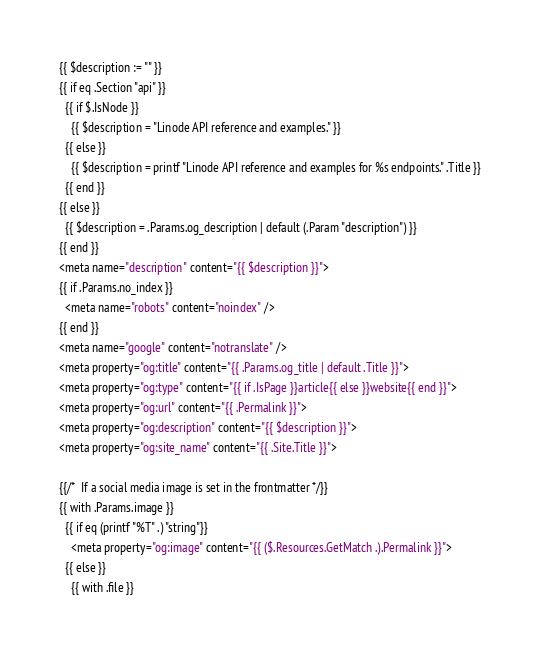Convert code to text. <code><loc_0><loc_0><loc_500><loc_500><_HTML_>{{ $description := "" }}
{{ if eq .Section "api" }}
  {{ if $.IsNode }}
    {{ $description = "Linode API reference and examples." }}
  {{ else }}
    {{ $description = printf "Linode API reference and examples for %s endpoints." .Title }}
  {{ end }}
{{ else }}
  {{ $description = .Params.og_description | default (.Param "description") }}
{{ end }}
<meta name="description" content="{{ $description }}">
{{ if .Params.no_index }}
  <meta name="robots" content="noindex" />
{{ end }}
<meta name="google" content="notranslate" />
<meta property="og:title" content="{{ .Params.og_title | default .Title }}">
<meta property="og:type" content="{{ if .IsPage }}article{{ else }}website{{ end }}">
<meta property="og:url" content="{{ .Permalink }}">
<meta property="og:description" content="{{ $description }}">
<meta property="og:site_name" content="{{ .Site.Title }}">

{{/*  If a social media image is set in the frontmatter */}}
{{ with .Params.image }}
  {{ if eq (printf "%T" .) "string"}}
    <meta property="og:image" content="{{ ($.Resources.GetMatch .).Permalink }}">
  {{ else }}
    {{ with .file }}</code> 